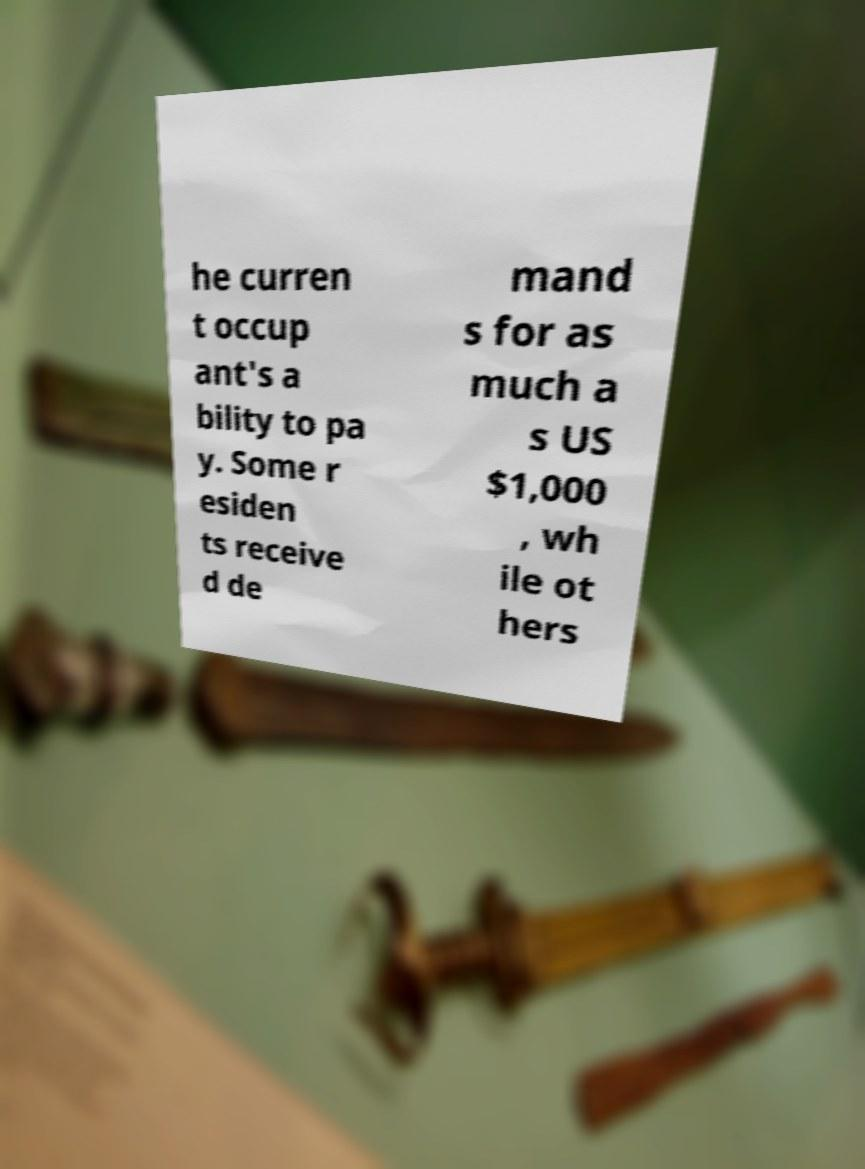Could you extract and type out the text from this image? he curren t occup ant's a bility to pa y. Some r esiden ts receive d de mand s for as much a s US $1,000 , wh ile ot hers 